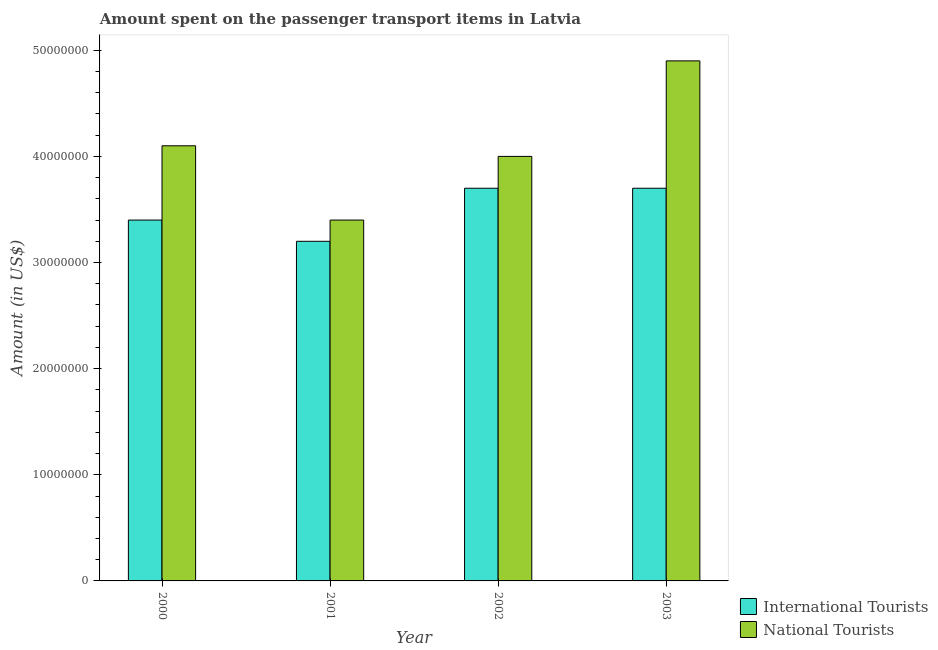How many different coloured bars are there?
Keep it short and to the point. 2. How many groups of bars are there?
Your answer should be very brief. 4. Are the number of bars per tick equal to the number of legend labels?
Give a very brief answer. Yes. What is the label of the 1st group of bars from the left?
Make the answer very short. 2000. What is the amount spent on transport items of international tourists in 2003?
Ensure brevity in your answer.  3.70e+07. Across all years, what is the maximum amount spent on transport items of national tourists?
Give a very brief answer. 4.90e+07. Across all years, what is the minimum amount spent on transport items of international tourists?
Your answer should be very brief. 3.20e+07. In which year was the amount spent on transport items of national tourists minimum?
Offer a very short reply. 2001. What is the total amount spent on transport items of international tourists in the graph?
Offer a terse response. 1.40e+08. What is the difference between the amount spent on transport items of national tourists in 2000 and that in 2001?
Make the answer very short. 7.00e+06. What is the difference between the amount spent on transport items of international tourists in 2000 and the amount spent on transport items of national tourists in 2002?
Give a very brief answer. -3.00e+06. What is the average amount spent on transport items of national tourists per year?
Keep it short and to the point. 4.10e+07. What is the ratio of the amount spent on transport items of national tourists in 2000 to that in 2003?
Keep it short and to the point. 0.84. Is the amount spent on transport items of international tourists in 2000 less than that in 2002?
Keep it short and to the point. Yes. Is the difference between the amount spent on transport items of international tourists in 2000 and 2002 greater than the difference between the amount spent on transport items of national tourists in 2000 and 2002?
Provide a short and direct response. No. What is the difference between the highest and the second highest amount spent on transport items of national tourists?
Your response must be concise. 8.00e+06. What is the difference between the highest and the lowest amount spent on transport items of national tourists?
Your answer should be compact. 1.50e+07. What does the 1st bar from the left in 2000 represents?
Provide a short and direct response. International Tourists. What does the 1st bar from the right in 2000 represents?
Your answer should be very brief. National Tourists. Are all the bars in the graph horizontal?
Keep it short and to the point. No. How many years are there in the graph?
Your answer should be very brief. 4. What is the difference between two consecutive major ticks on the Y-axis?
Give a very brief answer. 1.00e+07. Where does the legend appear in the graph?
Offer a terse response. Bottom right. How many legend labels are there?
Provide a short and direct response. 2. What is the title of the graph?
Your answer should be very brief. Amount spent on the passenger transport items in Latvia. Does "Quasi money growth" appear as one of the legend labels in the graph?
Provide a short and direct response. No. What is the label or title of the X-axis?
Offer a very short reply. Year. What is the Amount (in US$) in International Tourists in 2000?
Your answer should be very brief. 3.40e+07. What is the Amount (in US$) in National Tourists in 2000?
Offer a very short reply. 4.10e+07. What is the Amount (in US$) of International Tourists in 2001?
Offer a terse response. 3.20e+07. What is the Amount (in US$) in National Tourists in 2001?
Give a very brief answer. 3.40e+07. What is the Amount (in US$) in International Tourists in 2002?
Your answer should be very brief. 3.70e+07. What is the Amount (in US$) of National Tourists in 2002?
Provide a succinct answer. 4.00e+07. What is the Amount (in US$) of International Tourists in 2003?
Offer a very short reply. 3.70e+07. What is the Amount (in US$) of National Tourists in 2003?
Provide a short and direct response. 4.90e+07. Across all years, what is the maximum Amount (in US$) of International Tourists?
Offer a very short reply. 3.70e+07. Across all years, what is the maximum Amount (in US$) of National Tourists?
Offer a terse response. 4.90e+07. Across all years, what is the minimum Amount (in US$) in International Tourists?
Your response must be concise. 3.20e+07. Across all years, what is the minimum Amount (in US$) in National Tourists?
Make the answer very short. 3.40e+07. What is the total Amount (in US$) in International Tourists in the graph?
Your response must be concise. 1.40e+08. What is the total Amount (in US$) of National Tourists in the graph?
Offer a terse response. 1.64e+08. What is the difference between the Amount (in US$) in International Tourists in 2000 and that in 2001?
Give a very brief answer. 2.00e+06. What is the difference between the Amount (in US$) of International Tourists in 2000 and that in 2002?
Offer a very short reply. -3.00e+06. What is the difference between the Amount (in US$) in National Tourists in 2000 and that in 2002?
Offer a terse response. 1.00e+06. What is the difference between the Amount (in US$) in National Tourists in 2000 and that in 2003?
Offer a very short reply. -8.00e+06. What is the difference between the Amount (in US$) in International Tourists in 2001 and that in 2002?
Make the answer very short. -5.00e+06. What is the difference between the Amount (in US$) of National Tourists in 2001 and that in 2002?
Give a very brief answer. -6.00e+06. What is the difference between the Amount (in US$) in International Tourists in 2001 and that in 2003?
Make the answer very short. -5.00e+06. What is the difference between the Amount (in US$) of National Tourists in 2001 and that in 2003?
Offer a very short reply. -1.50e+07. What is the difference between the Amount (in US$) in International Tourists in 2002 and that in 2003?
Your response must be concise. 0. What is the difference between the Amount (in US$) in National Tourists in 2002 and that in 2003?
Ensure brevity in your answer.  -9.00e+06. What is the difference between the Amount (in US$) of International Tourists in 2000 and the Amount (in US$) of National Tourists in 2002?
Ensure brevity in your answer.  -6.00e+06. What is the difference between the Amount (in US$) in International Tourists in 2000 and the Amount (in US$) in National Tourists in 2003?
Ensure brevity in your answer.  -1.50e+07. What is the difference between the Amount (in US$) in International Tourists in 2001 and the Amount (in US$) in National Tourists in 2002?
Offer a terse response. -8.00e+06. What is the difference between the Amount (in US$) of International Tourists in 2001 and the Amount (in US$) of National Tourists in 2003?
Your response must be concise. -1.70e+07. What is the difference between the Amount (in US$) of International Tourists in 2002 and the Amount (in US$) of National Tourists in 2003?
Your response must be concise. -1.20e+07. What is the average Amount (in US$) of International Tourists per year?
Your answer should be compact. 3.50e+07. What is the average Amount (in US$) in National Tourists per year?
Your response must be concise. 4.10e+07. In the year 2000, what is the difference between the Amount (in US$) of International Tourists and Amount (in US$) of National Tourists?
Keep it short and to the point. -7.00e+06. In the year 2001, what is the difference between the Amount (in US$) of International Tourists and Amount (in US$) of National Tourists?
Your answer should be compact. -2.00e+06. In the year 2002, what is the difference between the Amount (in US$) of International Tourists and Amount (in US$) of National Tourists?
Offer a very short reply. -3.00e+06. In the year 2003, what is the difference between the Amount (in US$) in International Tourists and Amount (in US$) in National Tourists?
Give a very brief answer. -1.20e+07. What is the ratio of the Amount (in US$) in National Tourists in 2000 to that in 2001?
Offer a very short reply. 1.21. What is the ratio of the Amount (in US$) in International Tourists in 2000 to that in 2002?
Offer a terse response. 0.92. What is the ratio of the Amount (in US$) in National Tourists in 2000 to that in 2002?
Your answer should be very brief. 1.02. What is the ratio of the Amount (in US$) of International Tourists in 2000 to that in 2003?
Provide a succinct answer. 0.92. What is the ratio of the Amount (in US$) in National Tourists in 2000 to that in 2003?
Keep it short and to the point. 0.84. What is the ratio of the Amount (in US$) in International Tourists in 2001 to that in 2002?
Make the answer very short. 0.86. What is the ratio of the Amount (in US$) of National Tourists in 2001 to that in 2002?
Your response must be concise. 0.85. What is the ratio of the Amount (in US$) in International Tourists in 2001 to that in 2003?
Offer a very short reply. 0.86. What is the ratio of the Amount (in US$) in National Tourists in 2001 to that in 2003?
Your answer should be very brief. 0.69. What is the ratio of the Amount (in US$) of National Tourists in 2002 to that in 2003?
Make the answer very short. 0.82. What is the difference between the highest and the second highest Amount (in US$) in International Tourists?
Provide a short and direct response. 0. What is the difference between the highest and the lowest Amount (in US$) of International Tourists?
Your answer should be very brief. 5.00e+06. What is the difference between the highest and the lowest Amount (in US$) of National Tourists?
Your response must be concise. 1.50e+07. 